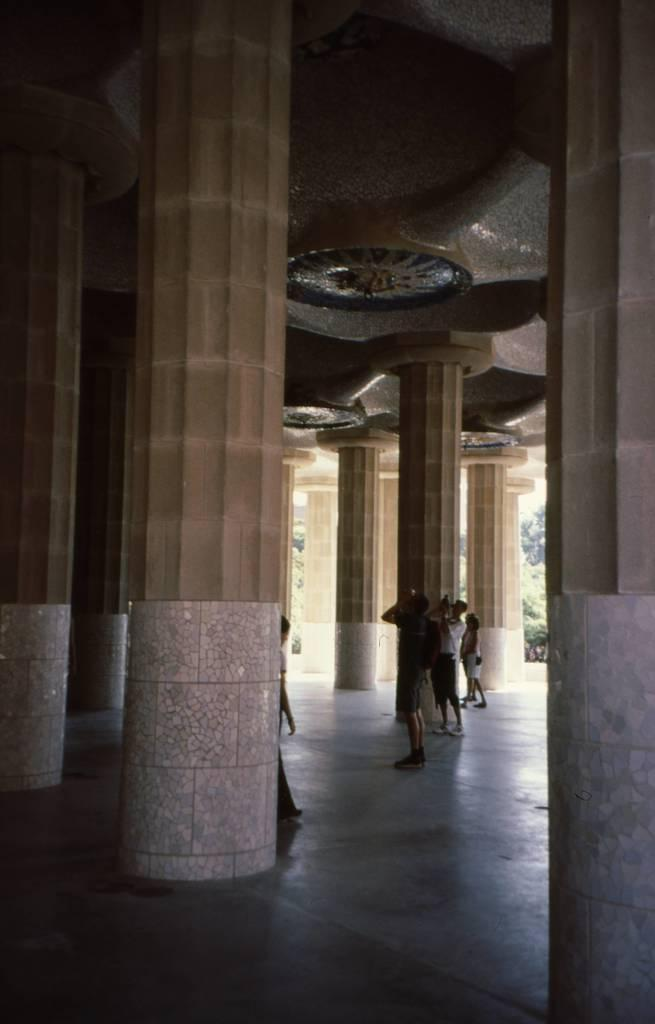What architectural features can be seen in the image? There are pillars in the image. Who or what is present in the image? There are people in the image. What surface can be seen under the people and pillars? There is a floor visible in the image. What can be seen in the distance behind the people and pillars? There are trees in the background of the image. What is above the people and pillars? The ceiling is visible in the image. What type of pear is being used to express anger in the image? There is no pear or expression of anger present in the image. What kind of treatment is being administered to the people in the image? There is no treatment being administered to the people in the image; they are simply standing or walking. 